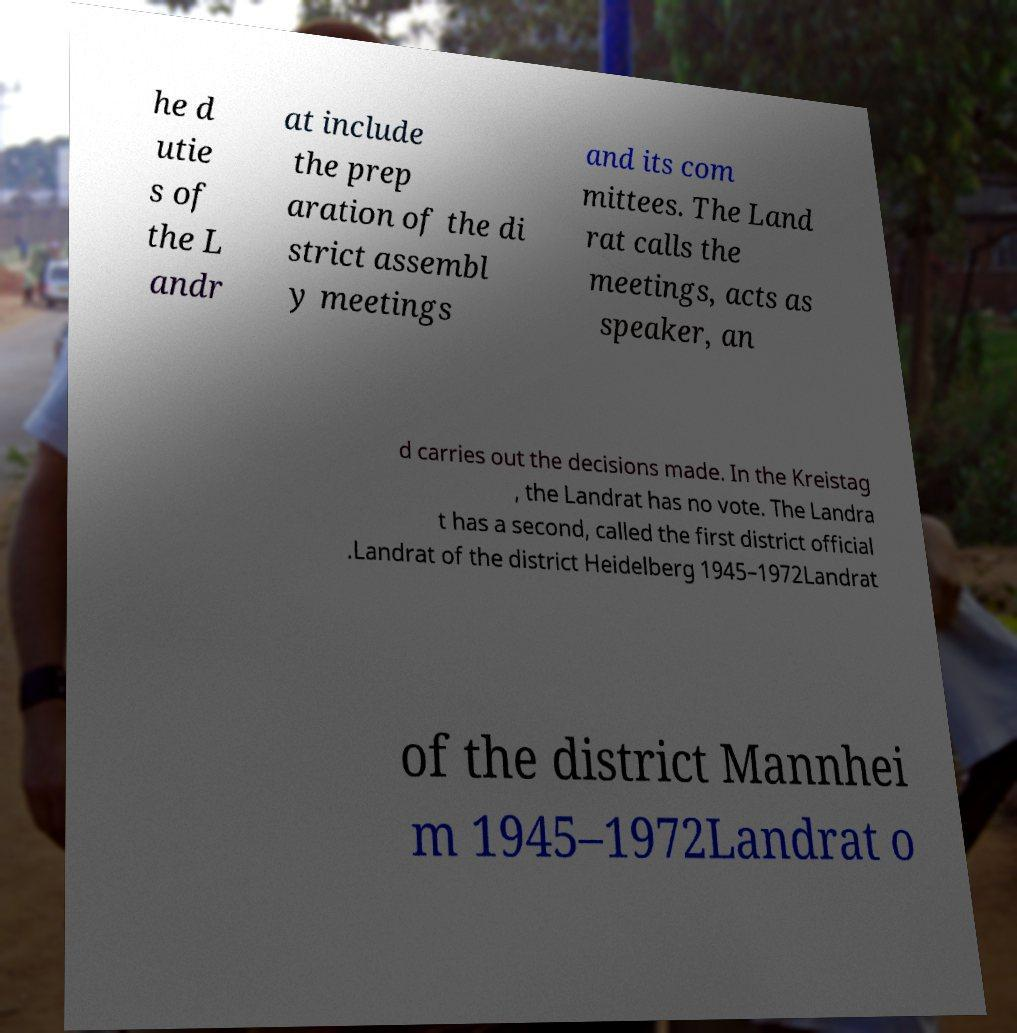There's text embedded in this image that I need extracted. Can you transcribe it verbatim? he d utie s of the L andr at include the prep aration of the di strict assembl y meetings and its com mittees. The Land rat calls the meetings, acts as speaker, an d carries out the decisions made. In the Kreistag , the Landrat has no vote. The Landra t has a second, called the first district official .Landrat of the district Heidelberg 1945–1972Landrat of the district Mannhei m 1945–1972Landrat o 